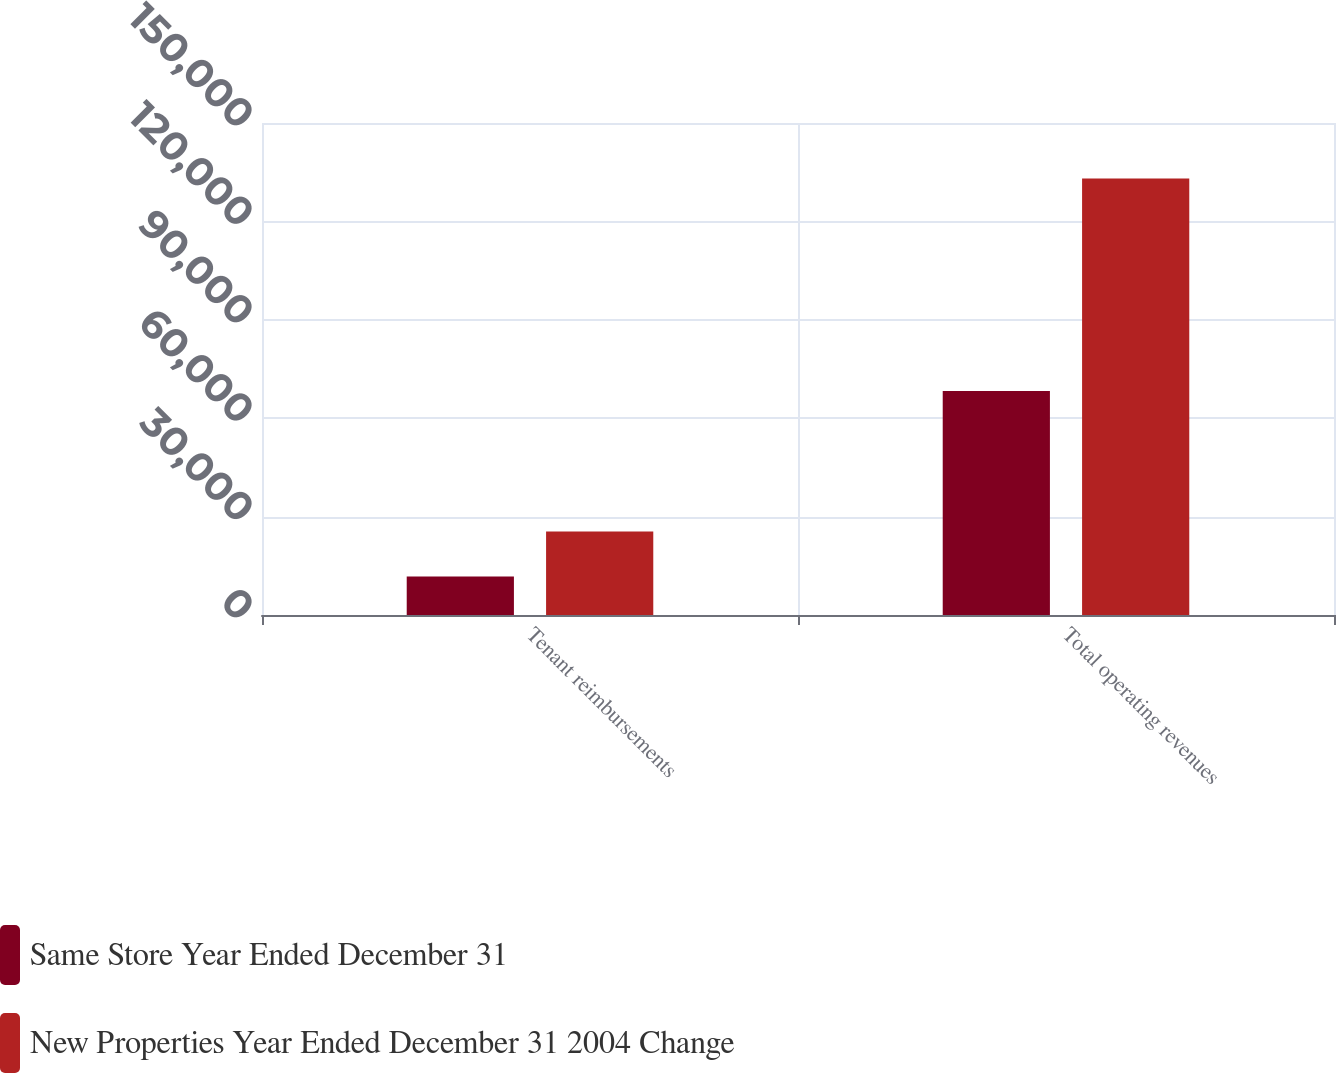<chart> <loc_0><loc_0><loc_500><loc_500><stacked_bar_chart><ecel><fcel>Tenant reimbursements<fcel>Total operating revenues<nl><fcel>Same Store Year Ended December 31<fcel>11735<fcel>68317<nl><fcel>New Properties Year Ended December 31 2004 Change<fcel>25439<fcel>133112<nl></chart> 